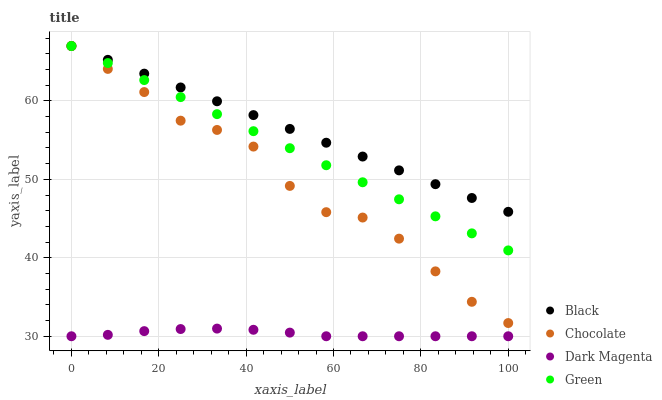Does Dark Magenta have the minimum area under the curve?
Answer yes or no. Yes. Does Black have the maximum area under the curve?
Answer yes or no. Yes. Does Black have the minimum area under the curve?
Answer yes or no. No. Does Dark Magenta have the maximum area under the curve?
Answer yes or no. No. Is Black the smoothest?
Answer yes or no. Yes. Is Chocolate the roughest?
Answer yes or no. Yes. Is Dark Magenta the smoothest?
Answer yes or no. No. Is Dark Magenta the roughest?
Answer yes or no. No. Does Dark Magenta have the lowest value?
Answer yes or no. Yes. Does Black have the lowest value?
Answer yes or no. No. Does Chocolate have the highest value?
Answer yes or no. Yes. Does Dark Magenta have the highest value?
Answer yes or no. No. Is Dark Magenta less than Chocolate?
Answer yes or no. Yes. Is Green greater than Dark Magenta?
Answer yes or no. Yes. Does Chocolate intersect Black?
Answer yes or no. Yes. Is Chocolate less than Black?
Answer yes or no. No. Is Chocolate greater than Black?
Answer yes or no. No. Does Dark Magenta intersect Chocolate?
Answer yes or no. No. 